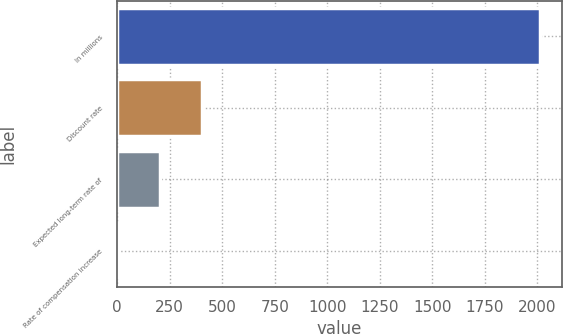<chart> <loc_0><loc_0><loc_500><loc_500><bar_chart><fcel>In millions<fcel>Discount rate<fcel>Expected long-term rate of<fcel>Rate of compensation increase<nl><fcel>2015<fcel>403.8<fcel>202.4<fcel>1<nl></chart> 